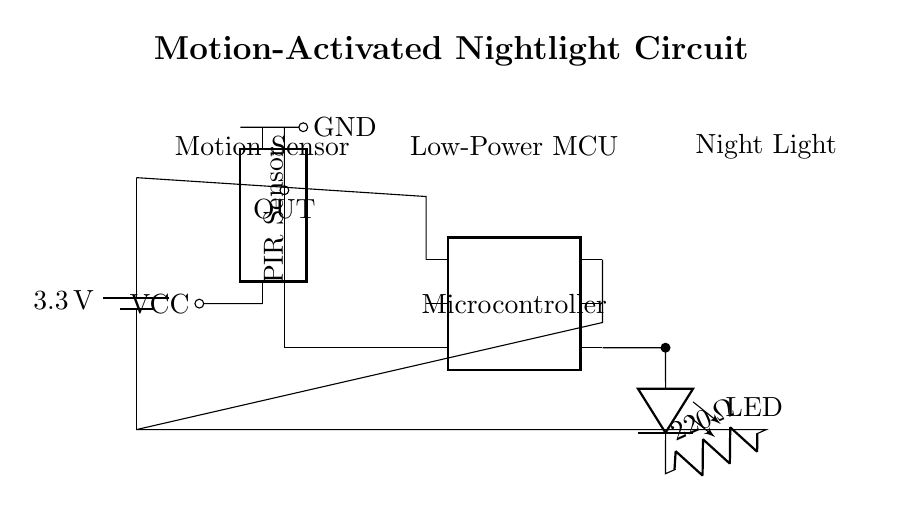What is the voltage of this circuit? The voltage is 3.3 volts, as indicated by the battery symbol at the top part of the circuit diagram.
Answer: 3.3 volts What type of sensor is used in this circuit? A passive infrared sensor is identifiable by the "PIR Sensor" label in the circuit diagram, which is used to detect motion.
Answer: Passive infrared sensor How many pins does the microcontroller have? The microcontroller is shown as a dip chip with six pins, indicated by the "num pins=6" label.
Answer: Six pins What component connects the microcontroller to the LED? The connection from pin four of the microcontroller to the LED is shown with a short line in the circuit diagram, making the connection explicit.
Answer: Microcontroller pin four Explain the purpose of the resistor in this circuit. The resistor, labeled as "220 ohms," is connected in series with the LED, which limits the current flowing through the LED to prevent it from burning out due to excess current.
Answer: Current limiting What activates the nightlight according to the diagram? The nightlight is activated by the output from the PIR sensor, which sends a signal to the microcontroller when motion is detected, turning the LED on.
Answer: Motion detected Which component provides ground in this circuit? The ground in this circuit is indicated by the "GND" label connected to the PIR sensor and the microcontroller, which connects to the negative side of the power supply.
Answer: Ground 